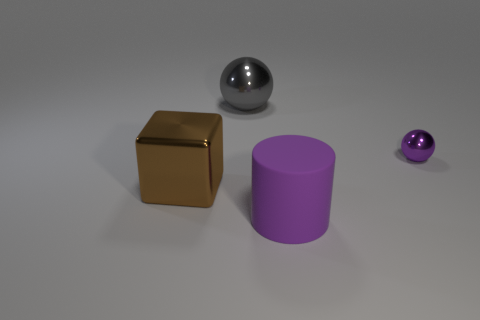There is a big matte thing that is the same color as the small metallic thing; what is its shape?
Give a very brief answer. Cylinder. The block that is the same material as the big ball is what color?
Make the answer very short. Brown. There is a metal thing that is both to the left of the tiny object and behind the cube; what size is it?
Your answer should be very brief. Large. What is the shape of the small purple thing?
Ensure brevity in your answer.  Sphere. Is there a purple ball that is behind the ball that is to the left of the large rubber object?
Provide a succinct answer. No. There is a object that is on the right side of the rubber cylinder; how many metal cubes are left of it?
Make the answer very short. 1. What material is the cylinder that is the same size as the gray metallic object?
Make the answer very short. Rubber. Do the shiny object right of the big gray ball and the gray object have the same shape?
Your answer should be compact. Yes. Are there more purple things that are to the left of the purple metal thing than large metallic blocks behind the brown block?
Give a very brief answer. Yes. How many things are the same material as the big gray ball?
Make the answer very short. 2. 